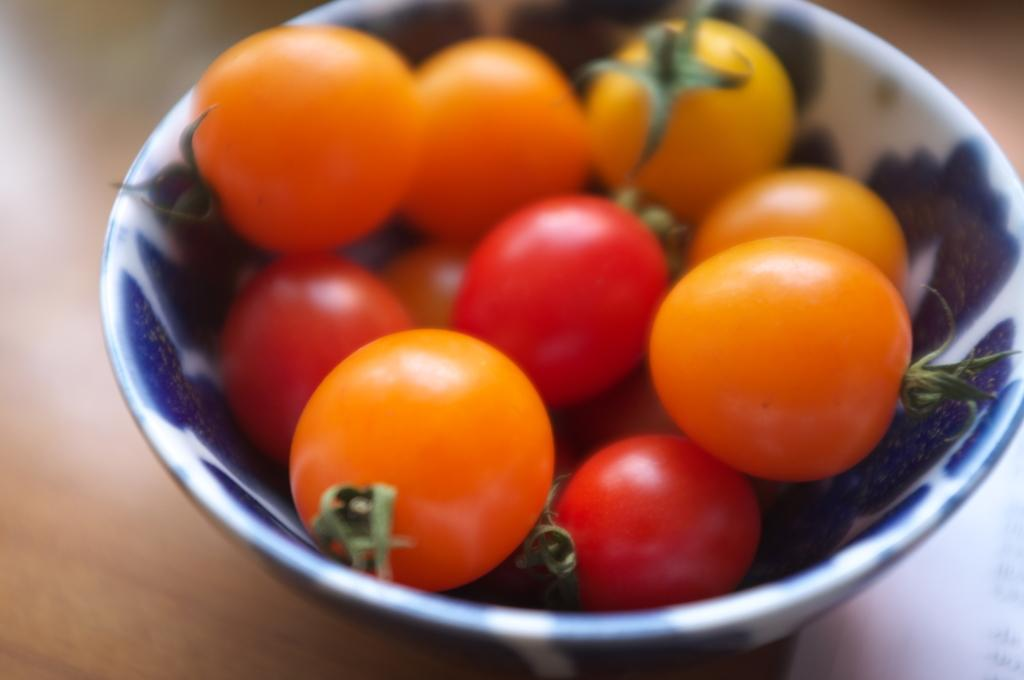What is in the bowl that is visible in the image? There is a bowl with tomatoes in it. Where is the bowl located in the image? The bowl is placed on a table. What part of the car can be seen in the image? There is no car present in the image; it features a bowl with tomatoes on a table. What type of arm is visible in the image? There are no arms visible in the image; it features a bowl with tomatoes on a table. 